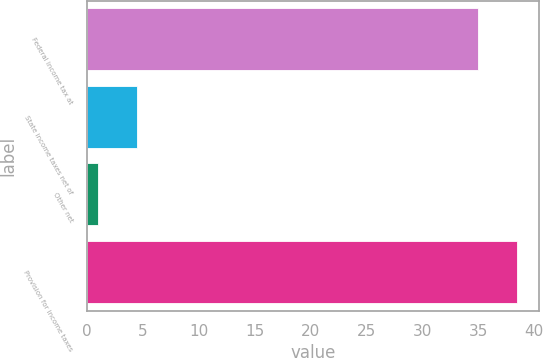Convert chart. <chart><loc_0><loc_0><loc_500><loc_500><bar_chart><fcel>Federal income tax at<fcel>State income taxes net of<fcel>Other net<fcel>Provision for income taxes<nl><fcel>35<fcel>4.5<fcel>1<fcel>38.5<nl></chart> 